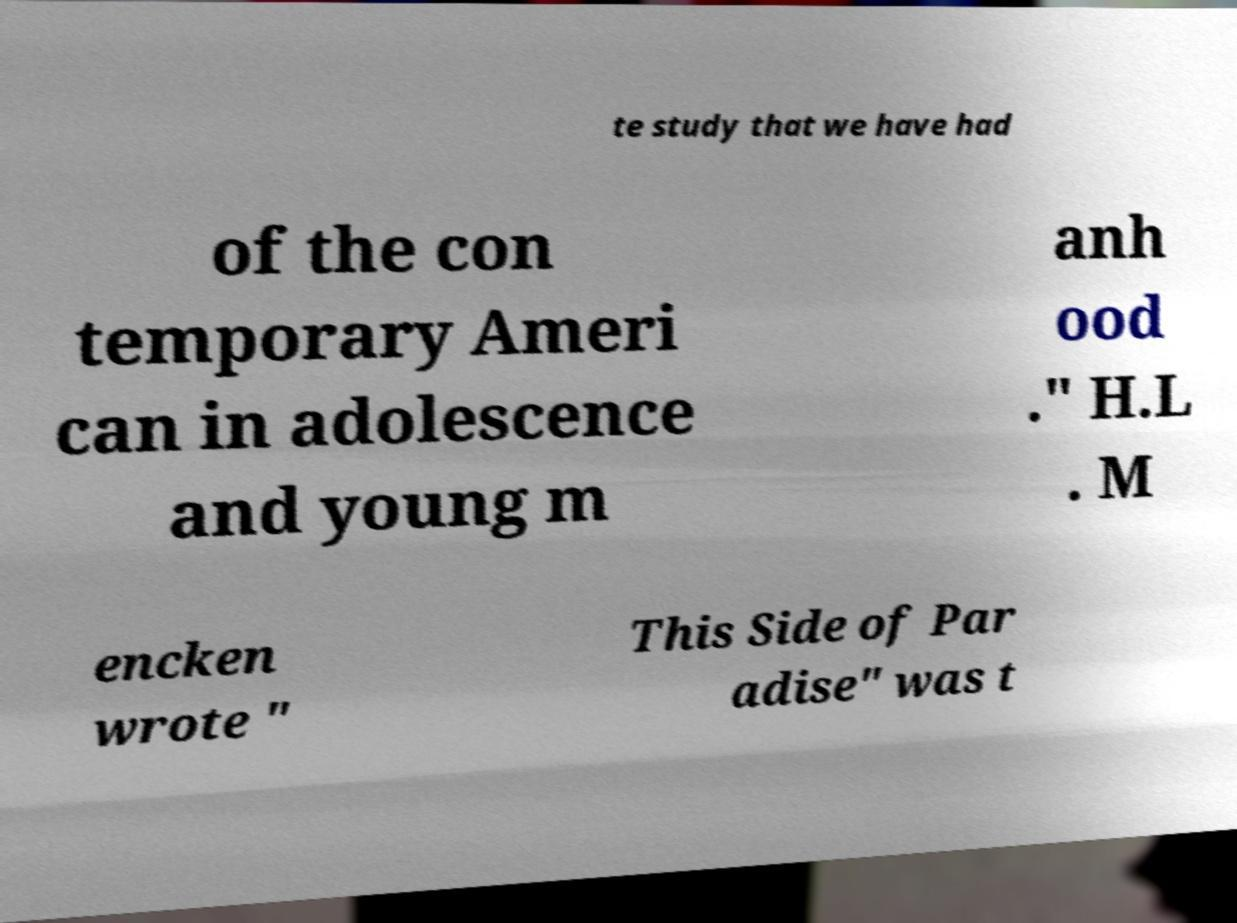What messages or text are displayed in this image? I need them in a readable, typed format. te study that we have had of the con temporary Ameri can in adolescence and young m anh ood ." H.L . M encken wrote " This Side of Par adise" was t 